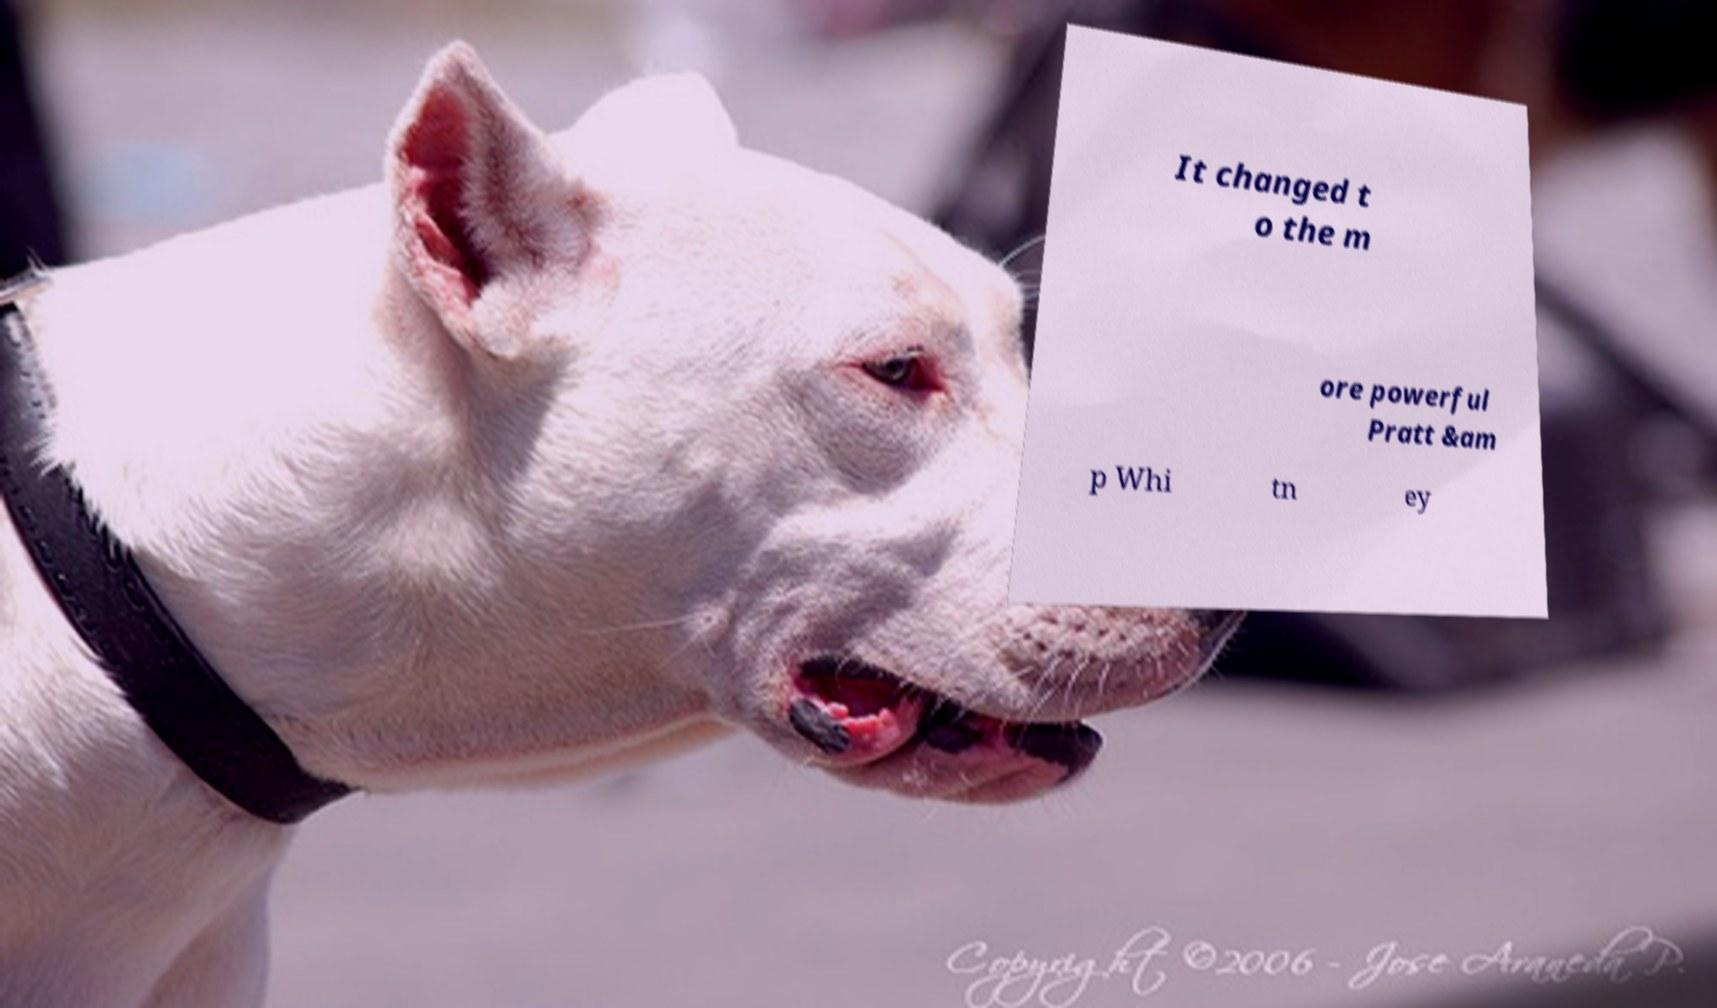Can you read and provide the text displayed in the image?This photo seems to have some interesting text. Can you extract and type it out for me? It changed t o the m ore powerful Pratt &am p Whi tn ey 